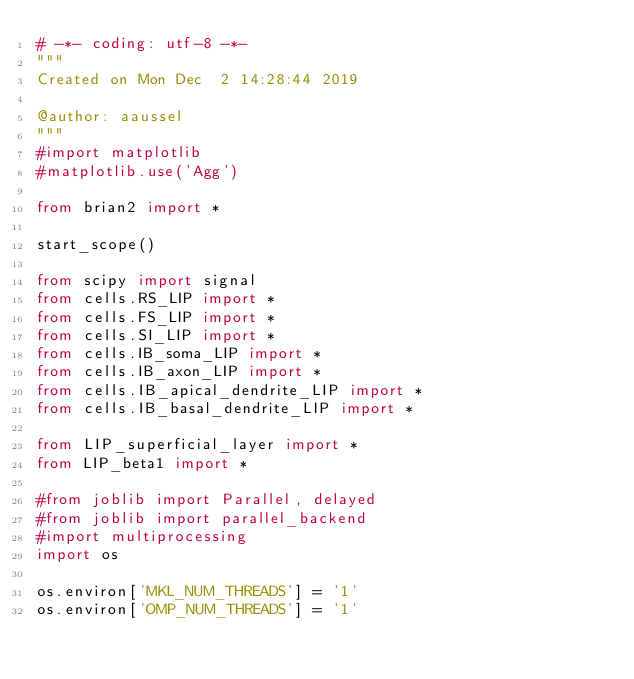<code> <loc_0><loc_0><loc_500><loc_500><_Python_># -*- coding: utf-8 -*-
"""
Created on Mon Dec  2 14:28:44 2019

@author: aaussel
"""
#import matplotlib
#matplotlib.use('Agg')

from brian2 import *

start_scope()

from scipy import signal
from cells.RS_LIP import *
from cells.FS_LIP import *
from cells.SI_LIP import *
from cells.IB_soma_LIP import *
from cells.IB_axon_LIP import *
from cells.IB_apical_dendrite_LIP import *
from cells.IB_basal_dendrite_LIP import *

from LIP_superficial_layer import *
from LIP_beta1 import *

#from joblib import Parallel, delayed
#from joblib import parallel_backend
#import multiprocessing
import os

os.environ['MKL_NUM_THREADS'] = '1'
os.environ['OMP_NUM_THREADS'] = '1'</code> 